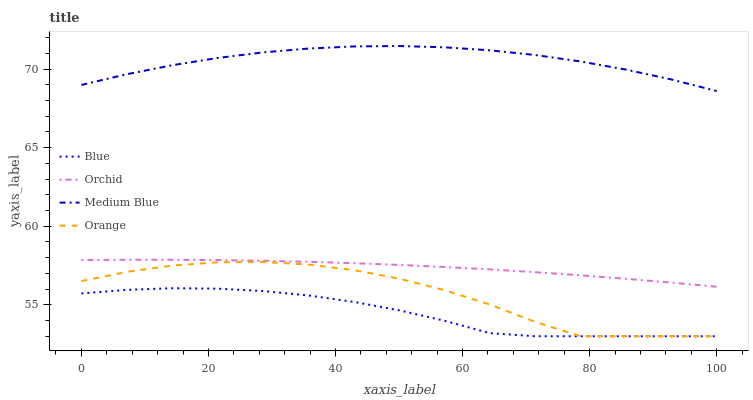Does Blue have the minimum area under the curve?
Answer yes or no. Yes. Does Medium Blue have the maximum area under the curve?
Answer yes or no. Yes. Does Orange have the minimum area under the curve?
Answer yes or no. No. Does Orange have the maximum area under the curve?
Answer yes or no. No. Is Orchid the smoothest?
Answer yes or no. Yes. Is Orange the roughest?
Answer yes or no. Yes. Is Medium Blue the smoothest?
Answer yes or no. No. Is Medium Blue the roughest?
Answer yes or no. No. Does Blue have the lowest value?
Answer yes or no. Yes. Does Medium Blue have the lowest value?
Answer yes or no. No. Does Medium Blue have the highest value?
Answer yes or no. Yes. Does Orange have the highest value?
Answer yes or no. No. Is Blue less than Orchid?
Answer yes or no. Yes. Is Medium Blue greater than Blue?
Answer yes or no. Yes. Does Blue intersect Orange?
Answer yes or no. Yes. Is Blue less than Orange?
Answer yes or no. No. Is Blue greater than Orange?
Answer yes or no. No. Does Blue intersect Orchid?
Answer yes or no. No. 